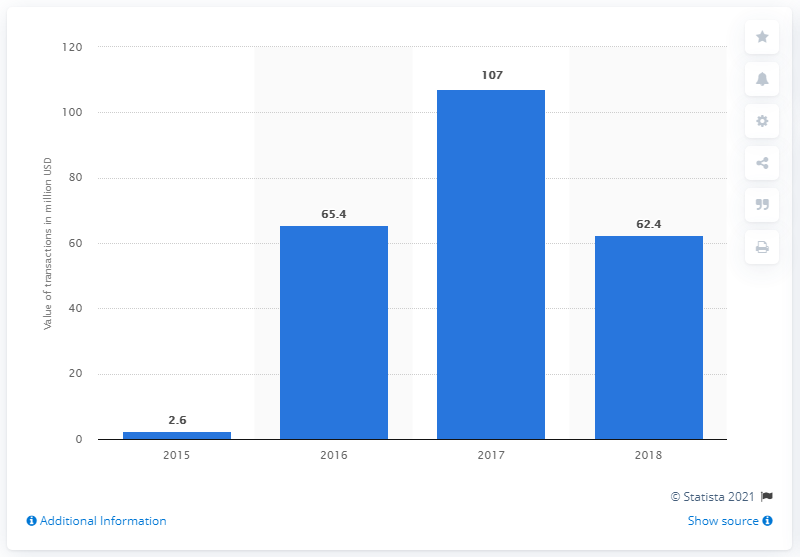Highlight a few significant elements in this photo. In 2018, the total transaction value of donation-based crowdfunding in the United States was approximately 62.4 million dollars. 